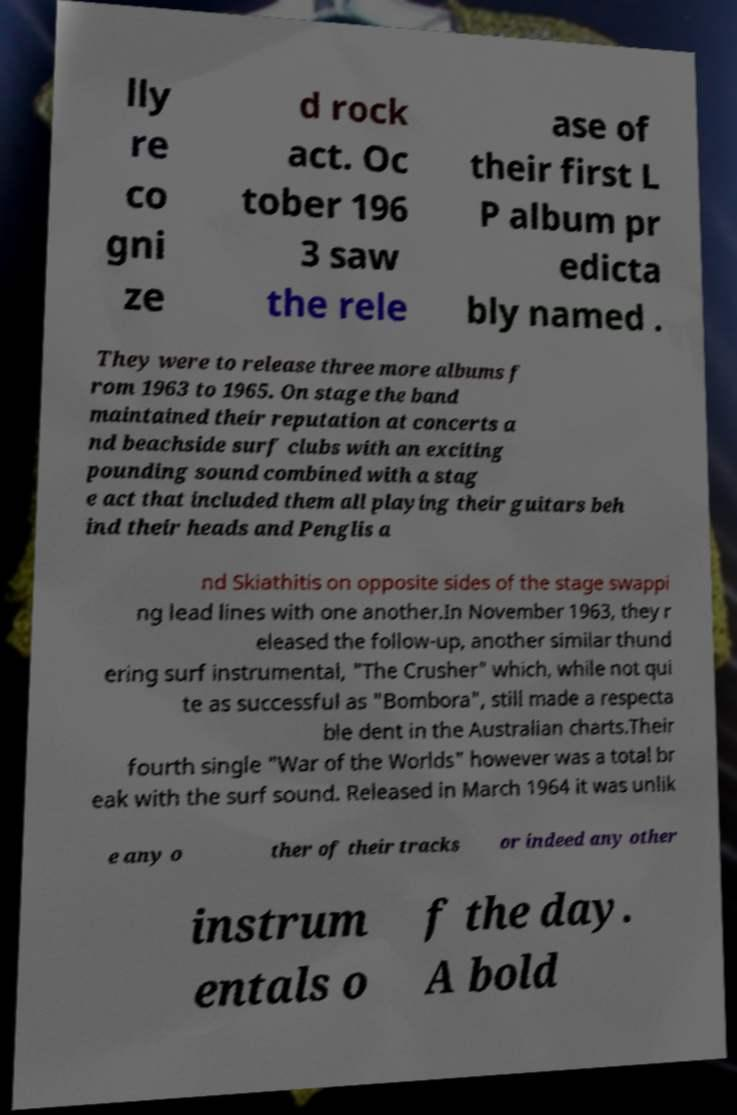There's text embedded in this image that I need extracted. Can you transcribe it verbatim? lly re co gni ze d rock act. Oc tober 196 3 saw the rele ase of their first L P album pr edicta bly named . They were to release three more albums f rom 1963 to 1965. On stage the band maintained their reputation at concerts a nd beachside surf clubs with an exciting pounding sound combined with a stag e act that included them all playing their guitars beh ind their heads and Penglis a nd Skiathitis on opposite sides of the stage swappi ng lead lines with one another.In November 1963, they r eleased the follow-up, another similar thund ering surf instrumental, "The Crusher" which, while not qui te as successful as "Bombora", still made a respecta ble dent in the Australian charts.Their fourth single "War of the Worlds" however was a total br eak with the surf sound. Released in March 1964 it was unlik e any o ther of their tracks or indeed any other instrum entals o f the day. A bold 